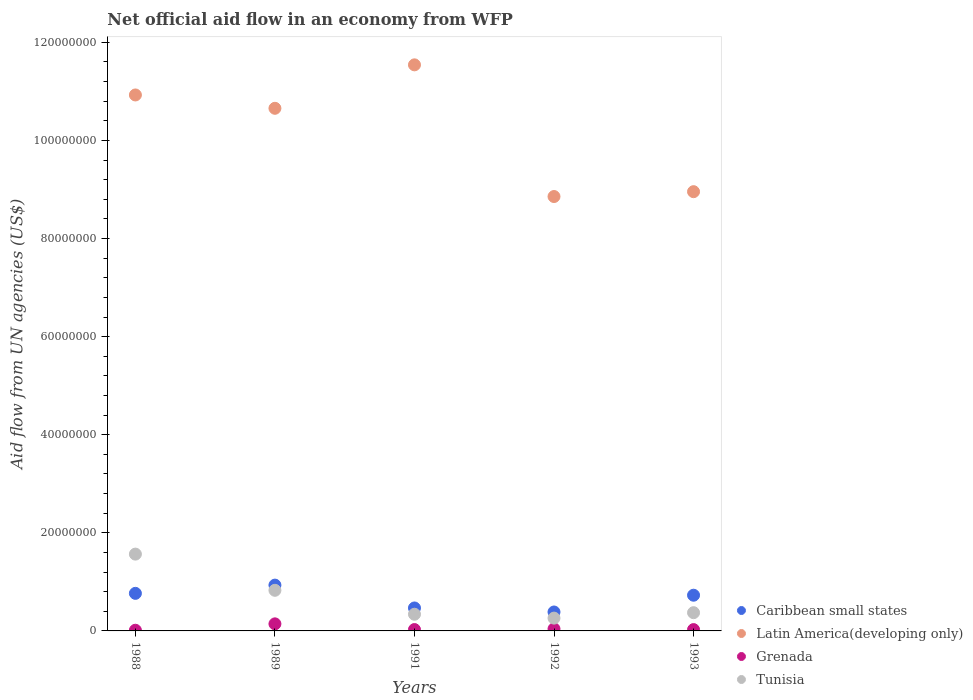How many different coloured dotlines are there?
Ensure brevity in your answer.  4. Is the number of dotlines equal to the number of legend labels?
Make the answer very short. Yes. Across all years, what is the maximum net official aid flow in Latin America(developing only)?
Keep it short and to the point. 1.15e+08. Across all years, what is the minimum net official aid flow in Caribbean small states?
Your answer should be very brief. 3.86e+06. In which year was the net official aid flow in Grenada minimum?
Offer a very short reply. 1988. What is the total net official aid flow in Latin America(developing only) in the graph?
Your response must be concise. 5.09e+08. What is the difference between the net official aid flow in Grenada in 1991 and that in 1992?
Provide a succinct answer. -1.40e+05. What is the difference between the net official aid flow in Tunisia in 1988 and the net official aid flow in Caribbean small states in 1992?
Offer a terse response. 1.18e+07. What is the average net official aid flow in Tunisia per year?
Ensure brevity in your answer.  6.73e+06. In the year 1991, what is the difference between the net official aid flow in Latin America(developing only) and net official aid flow in Tunisia?
Your response must be concise. 1.12e+08. What is the ratio of the net official aid flow in Caribbean small states in 1988 to that in 1991?
Ensure brevity in your answer.  1.64. Is the difference between the net official aid flow in Latin America(developing only) in 1991 and 1993 greater than the difference between the net official aid flow in Tunisia in 1991 and 1993?
Keep it short and to the point. Yes. What is the difference between the highest and the second highest net official aid flow in Caribbean small states?
Provide a succinct answer. 1.68e+06. What is the difference between the highest and the lowest net official aid flow in Tunisia?
Provide a succinct answer. 1.30e+07. In how many years, is the net official aid flow in Latin America(developing only) greater than the average net official aid flow in Latin America(developing only) taken over all years?
Provide a short and direct response. 3. Is the net official aid flow in Tunisia strictly greater than the net official aid flow in Latin America(developing only) over the years?
Ensure brevity in your answer.  No. How many dotlines are there?
Make the answer very short. 4. What is the difference between two consecutive major ticks on the Y-axis?
Provide a succinct answer. 2.00e+07. Does the graph contain any zero values?
Your answer should be very brief. No. How many legend labels are there?
Provide a succinct answer. 4. What is the title of the graph?
Make the answer very short. Net official aid flow in an economy from WFP. Does "Northern Mariana Islands" appear as one of the legend labels in the graph?
Your answer should be compact. No. What is the label or title of the Y-axis?
Provide a succinct answer. Aid flow from UN agencies (US$). What is the Aid flow from UN agencies (US$) in Caribbean small states in 1988?
Your response must be concise. 7.66e+06. What is the Aid flow from UN agencies (US$) of Latin America(developing only) in 1988?
Your answer should be compact. 1.09e+08. What is the Aid flow from UN agencies (US$) in Grenada in 1988?
Offer a terse response. 1.40e+05. What is the Aid flow from UN agencies (US$) in Tunisia in 1988?
Offer a terse response. 1.57e+07. What is the Aid flow from UN agencies (US$) in Caribbean small states in 1989?
Provide a short and direct response. 9.34e+06. What is the Aid flow from UN agencies (US$) of Latin America(developing only) in 1989?
Provide a succinct answer. 1.07e+08. What is the Aid flow from UN agencies (US$) in Grenada in 1989?
Offer a very short reply. 1.44e+06. What is the Aid flow from UN agencies (US$) in Tunisia in 1989?
Your answer should be very brief. 8.28e+06. What is the Aid flow from UN agencies (US$) in Caribbean small states in 1991?
Offer a terse response. 4.68e+06. What is the Aid flow from UN agencies (US$) in Latin America(developing only) in 1991?
Keep it short and to the point. 1.15e+08. What is the Aid flow from UN agencies (US$) in Tunisia in 1991?
Offer a terse response. 3.40e+06. What is the Aid flow from UN agencies (US$) in Caribbean small states in 1992?
Your answer should be compact. 3.86e+06. What is the Aid flow from UN agencies (US$) of Latin America(developing only) in 1992?
Provide a succinct answer. 8.86e+07. What is the Aid flow from UN agencies (US$) of Grenada in 1992?
Keep it short and to the point. 4.20e+05. What is the Aid flow from UN agencies (US$) of Tunisia in 1992?
Your answer should be compact. 2.61e+06. What is the Aid flow from UN agencies (US$) in Caribbean small states in 1993?
Your answer should be compact. 7.28e+06. What is the Aid flow from UN agencies (US$) in Latin America(developing only) in 1993?
Offer a very short reply. 8.96e+07. What is the Aid flow from UN agencies (US$) in Grenada in 1993?
Provide a succinct answer. 2.70e+05. What is the Aid flow from UN agencies (US$) in Tunisia in 1993?
Offer a very short reply. 3.72e+06. Across all years, what is the maximum Aid flow from UN agencies (US$) of Caribbean small states?
Keep it short and to the point. 9.34e+06. Across all years, what is the maximum Aid flow from UN agencies (US$) of Latin America(developing only)?
Keep it short and to the point. 1.15e+08. Across all years, what is the maximum Aid flow from UN agencies (US$) of Grenada?
Your response must be concise. 1.44e+06. Across all years, what is the maximum Aid flow from UN agencies (US$) in Tunisia?
Provide a short and direct response. 1.57e+07. Across all years, what is the minimum Aid flow from UN agencies (US$) in Caribbean small states?
Offer a very short reply. 3.86e+06. Across all years, what is the minimum Aid flow from UN agencies (US$) of Latin America(developing only)?
Offer a terse response. 8.86e+07. Across all years, what is the minimum Aid flow from UN agencies (US$) in Grenada?
Provide a short and direct response. 1.40e+05. Across all years, what is the minimum Aid flow from UN agencies (US$) of Tunisia?
Offer a terse response. 2.61e+06. What is the total Aid flow from UN agencies (US$) of Caribbean small states in the graph?
Offer a terse response. 3.28e+07. What is the total Aid flow from UN agencies (US$) in Latin America(developing only) in the graph?
Offer a terse response. 5.09e+08. What is the total Aid flow from UN agencies (US$) in Grenada in the graph?
Your answer should be very brief. 2.55e+06. What is the total Aid flow from UN agencies (US$) in Tunisia in the graph?
Ensure brevity in your answer.  3.37e+07. What is the difference between the Aid flow from UN agencies (US$) in Caribbean small states in 1988 and that in 1989?
Give a very brief answer. -1.68e+06. What is the difference between the Aid flow from UN agencies (US$) in Latin America(developing only) in 1988 and that in 1989?
Provide a short and direct response. 2.72e+06. What is the difference between the Aid flow from UN agencies (US$) in Grenada in 1988 and that in 1989?
Give a very brief answer. -1.30e+06. What is the difference between the Aid flow from UN agencies (US$) in Tunisia in 1988 and that in 1989?
Provide a succinct answer. 7.38e+06. What is the difference between the Aid flow from UN agencies (US$) in Caribbean small states in 1988 and that in 1991?
Give a very brief answer. 2.98e+06. What is the difference between the Aid flow from UN agencies (US$) in Latin America(developing only) in 1988 and that in 1991?
Ensure brevity in your answer.  -6.14e+06. What is the difference between the Aid flow from UN agencies (US$) of Grenada in 1988 and that in 1991?
Your response must be concise. -1.40e+05. What is the difference between the Aid flow from UN agencies (US$) of Tunisia in 1988 and that in 1991?
Provide a short and direct response. 1.23e+07. What is the difference between the Aid flow from UN agencies (US$) in Caribbean small states in 1988 and that in 1992?
Offer a very short reply. 3.80e+06. What is the difference between the Aid flow from UN agencies (US$) of Latin America(developing only) in 1988 and that in 1992?
Offer a very short reply. 2.07e+07. What is the difference between the Aid flow from UN agencies (US$) of Grenada in 1988 and that in 1992?
Keep it short and to the point. -2.80e+05. What is the difference between the Aid flow from UN agencies (US$) of Tunisia in 1988 and that in 1992?
Keep it short and to the point. 1.30e+07. What is the difference between the Aid flow from UN agencies (US$) of Latin America(developing only) in 1988 and that in 1993?
Provide a short and direct response. 1.97e+07. What is the difference between the Aid flow from UN agencies (US$) in Tunisia in 1988 and that in 1993?
Keep it short and to the point. 1.19e+07. What is the difference between the Aid flow from UN agencies (US$) of Caribbean small states in 1989 and that in 1991?
Offer a terse response. 4.66e+06. What is the difference between the Aid flow from UN agencies (US$) of Latin America(developing only) in 1989 and that in 1991?
Offer a terse response. -8.86e+06. What is the difference between the Aid flow from UN agencies (US$) of Grenada in 1989 and that in 1991?
Offer a terse response. 1.16e+06. What is the difference between the Aid flow from UN agencies (US$) of Tunisia in 1989 and that in 1991?
Provide a short and direct response. 4.88e+06. What is the difference between the Aid flow from UN agencies (US$) of Caribbean small states in 1989 and that in 1992?
Make the answer very short. 5.48e+06. What is the difference between the Aid flow from UN agencies (US$) of Latin America(developing only) in 1989 and that in 1992?
Keep it short and to the point. 1.80e+07. What is the difference between the Aid flow from UN agencies (US$) of Grenada in 1989 and that in 1992?
Make the answer very short. 1.02e+06. What is the difference between the Aid flow from UN agencies (US$) in Tunisia in 1989 and that in 1992?
Provide a short and direct response. 5.67e+06. What is the difference between the Aid flow from UN agencies (US$) in Caribbean small states in 1989 and that in 1993?
Your response must be concise. 2.06e+06. What is the difference between the Aid flow from UN agencies (US$) in Latin America(developing only) in 1989 and that in 1993?
Keep it short and to the point. 1.70e+07. What is the difference between the Aid flow from UN agencies (US$) of Grenada in 1989 and that in 1993?
Offer a very short reply. 1.17e+06. What is the difference between the Aid flow from UN agencies (US$) of Tunisia in 1989 and that in 1993?
Offer a very short reply. 4.56e+06. What is the difference between the Aid flow from UN agencies (US$) in Caribbean small states in 1991 and that in 1992?
Your response must be concise. 8.20e+05. What is the difference between the Aid flow from UN agencies (US$) in Latin America(developing only) in 1991 and that in 1992?
Keep it short and to the point. 2.68e+07. What is the difference between the Aid flow from UN agencies (US$) of Tunisia in 1991 and that in 1992?
Keep it short and to the point. 7.90e+05. What is the difference between the Aid flow from UN agencies (US$) in Caribbean small states in 1991 and that in 1993?
Keep it short and to the point. -2.60e+06. What is the difference between the Aid flow from UN agencies (US$) of Latin America(developing only) in 1991 and that in 1993?
Ensure brevity in your answer.  2.59e+07. What is the difference between the Aid flow from UN agencies (US$) of Grenada in 1991 and that in 1993?
Ensure brevity in your answer.  10000. What is the difference between the Aid flow from UN agencies (US$) of Tunisia in 1991 and that in 1993?
Your response must be concise. -3.20e+05. What is the difference between the Aid flow from UN agencies (US$) of Caribbean small states in 1992 and that in 1993?
Your answer should be very brief. -3.42e+06. What is the difference between the Aid flow from UN agencies (US$) of Latin America(developing only) in 1992 and that in 1993?
Make the answer very short. -9.90e+05. What is the difference between the Aid flow from UN agencies (US$) in Grenada in 1992 and that in 1993?
Provide a short and direct response. 1.50e+05. What is the difference between the Aid flow from UN agencies (US$) in Tunisia in 1992 and that in 1993?
Make the answer very short. -1.11e+06. What is the difference between the Aid flow from UN agencies (US$) in Caribbean small states in 1988 and the Aid flow from UN agencies (US$) in Latin America(developing only) in 1989?
Ensure brevity in your answer.  -9.89e+07. What is the difference between the Aid flow from UN agencies (US$) in Caribbean small states in 1988 and the Aid flow from UN agencies (US$) in Grenada in 1989?
Keep it short and to the point. 6.22e+06. What is the difference between the Aid flow from UN agencies (US$) of Caribbean small states in 1988 and the Aid flow from UN agencies (US$) of Tunisia in 1989?
Offer a terse response. -6.20e+05. What is the difference between the Aid flow from UN agencies (US$) in Latin America(developing only) in 1988 and the Aid flow from UN agencies (US$) in Grenada in 1989?
Offer a terse response. 1.08e+08. What is the difference between the Aid flow from UN agencies (US$) in Latin America(developing only) in 1988 and the Aid flow from UN agencies (US$) in Tunisia in 1989?
Keep it short and to the point. 1.01e+08. What is the difference between the Aid flow from UN agencies (US$) of Grenada in 1988 and the Aid flow from UN agencies (US$) of Tunisia in 1989?
Provide a succinct answer. -8.14e+06. What is the difference between the Aid flow from UN agencies (US$) of Caribbean small states in 1988 and the Aid flow from UN agencies (US$) of Latin America(developing only) in 1991?
Offer a very short reply. -1.08e+08. What is the difference between the Aid flow from UN agencies (US$) of Caribbean small states in 1988 and the Aid flow from UN agencies (US$) of Grenada in 1991?
Your response must be concise. 7.38e+06. What is the difference between the Aid flow from UN agencies (US$) in Caribbean small states in 1988 and the Aid flow from UN agencies (US$) in Tunisia in 1991?
Your answer should be very brief. 4.26e+06. What is the difference between the Aid flow from UN agencies (US$) of Latin America(developing only) in 1988 and the Aid flow from UN agencies (US$) of Grenada in 1991?
Your response must be concise. 1.09e+08. What is the difference between the Aid flow from UN agencies (US$) of Latin America(developing only) in 1988 and the Aid flow from UN agencies (US$) of Tunisia in 1991?
Offer a terse response. 1.06e+08. What is the difference between the Aid flow from UN agencies (US$) in Grenada in 1988 and the Aid flow from UN agencies (US$) in Tunisia in 1991?
Provide a succinct answer. -3.26e+06. What is the difference between the Aid flow from UN agencies (US$) in Caribbean small states in 1988 and the Aid flow from UN agencies (US$) in Latin America(developing only) in 1992?
Your response must be concise. -8.09e+07. What is the difference between the Aid flow from UN agencies (US$) of Caribbean small states in 1988 and the Aid flow from UN agencies (US$) of Grenada in 1992?
Your response must be concise. 7.24e+06. What is the difference between the Aid flow from UN agencies (US$) of Caribbean small states in 1988 and the Aid flow from UN agencies (US$) of Tunisia in 1992?
Keep it short and to the point. 5.05e+06. What is the difference between the Aid flow from UN agencies (US$) in Latin America(developing only) in 1988 and the Aid flow from UN agencies (US$) in Grenada in 1992?
Provide a succinct answer. 1.09e+08. What is the difference between the Aid flow from UN agencies (US$) of Latin America(developing only) in 1988 and the Aid flow from UN agencies (US$) of Tunisia in 1992?
Your response must be concise. 1.07e+08. What is the difference between the Aid flow from UN agencies (US$) in Grenada in 1988 and the Aid flow from UN agencies (US$) in Tunisia in 1992?
Offer a terse response. -2.47e+06. What is the difference between the Aid flow from UN agencies (US$) of Caribbean small states in 1988 and the Aid flow from UN agencies (US$) of Latin America(developing only) in 1993?
Your answer should be compact. -8.19e+07. What is the difference between the Aid flow from UN agencies (US$) in Caribbean small states in 1988 and the Aid flow from UN agencies (US$) in Grenada in 1993?
Offer a terse response. 7.39e+06. What is the difference between the Aid flow from UN agencies (US$) of Caribbean small states in 1988 and the Aid flow from UN agencies (US$) of Tunisia in 1993?
Your response must be concise. 3.94e+06. What is the difference between the Aid flow from UN agencies (US$) in Latin America(developing only) in 1988 and the Aid flow from UN agencies (US$) in Grenada in 1993?
Provide a succinct answer. 1.09e+08. What is the difference between the Aid flow from UN agencies (US$) of Latin America(developing only) in 1988 and the Aid flow from UN agencies (US$) of Tunisia in 1993?
Your answer should be very brief. 1.06e+08. What is the difference between the Aid flow from UN agencies (US$) of Grenada in 1988 and the Aid flow from UN agencies (US$) of Tunisia in 1993?
Ensure brevity in your answer.  -3.58e+06. What is the difference between the Aid flow from UN agencies (US$) of Caribbean small states in 1989 and the Aid flow from UN agencies (US$) of Latin America(developing only) in 1991?
Your answer should be very brief. -1.06e+08. What is the difference between the Aid flow from UN agencies (US$) in Caribbean small states in 1989 and the Aid flow from UN agencies (US$) in Grenada in 1991?
Ensure brevity in your answer.  9.06e+06. What is the difference between the Aid flow from UN agencies (US$) of Caribbean small states in 1989 and the Aid flow from UN agencies (US$) of Tunisia in 1991?
Your answer should be very brief. 5.94e+06. What is the difference between the Aid flow from UN agencies (US$) in Latin America(developing only) in 1989 and the Aid flow from UN agencies (US$) in Grenada in 1991?
Your response must be concise. 1.06e+08. What is the difference between the Aid flow from UN agencies (US$) of Latin America(developing only) in 1989 and the Aid flow from UN agencies (US$) of Tunisia in 1991?
Your answer should be compact. 1.03e+08. What is the difference between the Aid flow from UN agencies (US$) in Grenada in 1989 and the Aid flow from UN agencies (US$) in Tunisia in 1991?
Your answer should be compact. -1.96e+06. What is the difference between the Aid flow from UN agencies (US$) in Caribbean small states in 1989 and the Aid flow from UN agencies (US$) in Latin America(developing only) in 1992?
Offer a terse response. -7.92e+07. What is the difference between the Aid flow from UN agencies (US$) of Caribbean small states in 1989 and the Aid flow from UN agencies (US$) of Grenada in 1992?
Your answer should be compact. 8.92e+06. What is the difference between the Aid flow from UN agencies (US$) in Caribbean small states in 1989 and the Aid flow from UN agencies (US$) in Tunisia in 1992?
Give a very brief answer. 6.73e+06. What is the difference between the Aid flow from UN agencies (US$) of Latin America(developing only) in 1989 and the Aid flow from UN agencies (US$) of Grenada in 1992?
Your answer should be very brief. 1.06e+08. What is the difference between the Aid flow from UN agencies (US$) of Latin America(developing only) in 1989 and the Aid flow from UN agencies (US$) of Tunisia in 1992?
Keep it short and to the point. 1.04e+08. What is the difference between the Aid flow from UN agencies (US$) of Grenada in 1989 and the Aid flow from UN agencies (US$) of Tunisia in 1992?
Make the answer very short. -1.17e+06. What is the difference between the Aid flow from UN agencies (US$) in Caribbean small states in 1989 and the Aid flow from UN agencies (US$) in Latin America(developing only) in 1993?
Make the answer very short. -8.02e+07. What is the difference between the Aid flow from UN agencies (US$) in Caribbean small states in 1989 and the Aid flow from UN agencies (US$) in Grenada in 1993?
Make the answer very short. 9.07e+06. What is the difference between the Aid flow from UN agencies (US$) of Caribbean small states in 1989 and the Aid flow from UN agencies (US$) of Tunisia in 1993?
Offer a very short reply. 5.62e+06. What is the difference between the Aid flow from UN agencies (US$) in Latin America(developing only) in 1989 and the Aid flow from UN agencies (US$) in Grenada in 1993?
Your answer should be very brief. 1.06e+08. What is the difference between the Aid flow from UN agencies (US$) in Latin America(developing only) in 1989 and the Aid flow from UN agencies (US$) in Tunisia in 1993?
Offer a very short reply. 1.03e+08. What is the difference between the Aid flow from UN agencies (US$) of Grenada in 1989 and the Aid flow from UN agencies (US$) of Tunisia in 1993?
Give a very brief answer. -2.28e+06. What is the difference between the Aid flow from UN agencies (US$) of Caribbean small states in 1991 and the Aid flow from UN agencies (US$) of Latin America(developing only) in 1992?
Your answer should be compact. -8.39e+07. What is the difference between the Aid flow from UN agencies (US$) of Caribbean small states in 1991 and the Aid flow from UN agencies (US$) of Grenada in 1992?
Your answer should be very brief. 4.26e+06. What is the difference between the Aid flow from UN agencies (US$) of Caribbean small states in 1991 and the Aid flow from UN agencies (US$) of Tunisia in 1992?
Your answer should be compact. 2.07e+06. What is the difference between the Aid flow from UN agencies (US$) of Latin America(developing only) in 1991 and the Aid flow from UN agencies (US$) of Grenada in 1992?
Your answer should be very brief. 1.15e+08. What is the difference between the Aid flow from UN agencies (US$) in Latin America(developing only) in 1991 and the Aid flow from UN agencies (US$) in Tunisia in 1992?
Provide a short and direct response. 1.13e+08. What is the difference between the Aid flow from UN agencies (US$) in Grenada in 1991 and the Aid flow from UN agencies (US$) in Tunisia in 1992?
Offer a terse response. -2.33e+06. What is the difference between the Aid flow from UN agencies (US$) of Caribbean small states in 1991 and the Aid flow from UN agencies (US$) of Latin America(developing only) in 1993?
Make the answer very short. -8.49e+07. What is the difference between the Aid flow from UN agencies (US$) in Caribbean small states in 1991 and the Aid flow from UN agencies (US$) in Grenada in 1993?
Make the answer very short. 4.41e+06. What is the difference between the Aid flow from UN agencies (US$) in Caribbean small states in 1991 and the Aid flow from UN agencies (US$) in Tunisia in 1993?
Offer a terse response. 9.60e+05. What is the difference between the Aid flow from UN agencies (US$) of Latin America(developing only) in 1991 and the Aid flow from UN agencies (US$) of Grenada in 1993?
Your answer should be compact. 1.15e+08. What is the difference between the Aid flow from UN agencies (US$) in Latin America(developing only) in 1991 and the Aid flow from UN agencies (US$) in Tunisia in 1993?
Ensure brevity in your answer.  1.12e+08. What is the difference between the Aid flow from UN agencies (US$) in Grenada in 1991 and the Aid flow from UN agencies (US$) in Tunisia in 1993?
Offer a terse response. -3.44e+06. What is the difference between the Aid flow from UN agencies (US$) of Caribbean small states in 1992 and the Aid flow from UN agencies (US$) of Latin America(developing only) in 1993?
Give a very brief answer. -8.57e+07. What is the difference between the Aid flow from UN agencies (US$) in Caribbean small states in 1992 and the Aid flow from UN agencies (US$) in Grenada in 1993?
Offer a terse response. 3.59e+06. What is the difference between the Aid flow from UN agencies (US$) of Caribbean small states in 1992 and the Aid flow from UN agencies (US$) of Tunisia in 1993?
Give a very brief answer. 1.40e+05. What is the difference between the Aid flow from UN agencies (US$) in Latin America(developing only) in 1992 and the Aid flow from UN agencies (US$) in Grenada in 1993?
Keep it short and to the point. 8.83e+07. What is the difference between the Aid flow from UN agencies (US$) in Latin America(developing only) in 1992 and the Aid flow from UN agencies (US$) in Tunisia in 1993?
Ensure brevity in your answer.  8.48e+07. What is the difference between the Aid flow from UN agencies (US$) in Grenada in 1992 and the Aid flow from UN agencies (US$) in Tunisia in 1993?
Your answer should be compact. -3.30e+06. What is the average Aid flow from UN agencies (US$) in Caribbean small states per year?
Your response must be concise. 6.56e+06. What is the average Aid flow from UN agencies (US$) in Latin America(developing only) per year?
Give a very brief answer. 1.02e+08. What is the average Aid flow from UN agencies (US$) in Grenada per year?
Your answer should be very brief. 5.10e+05. What is the average Aid flow from UN agencies (US$) of Tunisia per year?
Offer a very short reply. 6.73e+06. In the year 1988, what is the difference between the Aid flow from UN agencies (US$) in Caribbean small states and Aid flow from UN agencies (US$) in Latin America(developing only)?
Offer a very short reply. -1.02e+08. In the year 1988, what is the difference between the Aid flow from UN agencies (US$) in Caribbean small states and Aid flow from UN agencies (US$) in Grenada?
Give a very brief answer. 7.52e+06. In the year 1988, what is the difference between the Aid flow from UN agencies (US$) of Caribbean small states and Aid flow from UN agencies (US$) of Tunisia?
Your response must be concise. -8.00e+06. In the year 1988, what is the difference between the Aid flow from UN agencies (US$) in Latin America(developing only) and Aid flow from UN agencies (US$) in Grenada?
Keep it short and to the point. 1.09e+08. In the year 1988, what is the difference between the Aid flow from UN agencies (US$) of Latin America(developing only) and Aid flow from UN agencies (US$) of Tunisia?
Provide a succinct answer. 9.36e+07. In the year 1988, what is the difference between the Aid flow from UN agencies (US$) in Grenada and Aid flow from UN agencies (US$) in Tunisia?
Offer a terse response. -1.55e+07. In the year 1989, what is the difference between the Aid flow from UN agencies (US$) in Caribbean small states and Aid flow from UN agencies (US$) in Latin America(developing only)?
Your answer should be very brief. -9.72e+07. In the year 1989, what is the difference between the Aid flow from UN agencies (US$) in Caribbean small states and Aid flow from UN agencies (US$) in Grenada?
Your response must be concise. 7.90e+06. In the year 1989, what is the difference between the Aid flow from UN agencies (US$) of Caribbean small states and Aid flow from UN agencies (US$) of Tunisia?
Offer a terse response. 1.06e+06. In the year 1989, what is the difference between the Aid flow from UN agencies (US$) in Latin America(developing only) and Aid flow from UN agencies (US$) in Grenada?
Provide a succinct answer. 1.05e+08. In the year 1989, what is the difference between the Aid flow from UN agencies (US$) of Latin America(developing only) and Aid flow from UN agencies (US$) of Tunisia?
Give a very brief answer. 9.83e+07. In the year 1989, what is the difference between the Aid flow from UN agencies (US$) of Grenada and Aid flow from UN agencies (US$) of Tunisia?
Make the answer very short. -6.84e+06. In the year 1991, what is the difference between the Aid flow from UN agencies (US$) of Caribbean small states and Aid flow from UN agencies (US$) of Latin America(developing only)?
Make the answer very short. -1.11e+08. In the year 1991, what is the difference between the Aid flow from UN agencies (US$) in Caribbean small states and Aid flow from UN agencies (US$) in Grenada?
Offer a terse response. 4.40e+06. In the year 1991, what is the difference between the Aid flow from UN agencies (US$) of Caribbean small states and Aid flow from UN agencies (US$) of Tunisia?
Offer a terse response. 1.28e+06. In the year 1991, what is the difference between the Aid flow from UN agencies (US$) of Latin America(developing only) and Aid flow from UN agencies (US$) of Grenada?
Give a very brief answer. 1.15e+08. In the year 1991, what is the difference between the Aid flow from UN agencies (US$) of Latin America(developing only) and Aid flow from UN agencies (US$) of Tunisia?
Your answer should be compact. 1.12e+08. In the year 1991, what is the difference between the Aid flow from UN agencies (US$) of Grenada and Aid flow from UN agencies (US$) of Tunisia?
Make the answer very short. -3.12e+06. In the year 1992, what is the difference between the Aid flow from UN agencies (US$) of Caribbean small states and Aid flow from UN agencies (US$) of Latin America(developing only)?
Provide a short and direct response. -8.47e+07. In the year 1992, what is the difference between the Aid flow from UN agencies (US$) in Caribbean small states and Aid flow from UN agencies (US$) in Grenada?
Offer a very short reply. 3.44e+06. In the year 1992, what is the difference between the Aid flow from UN agencies (US$) of Caribbean small states and Aid flow from UN agencies (US$) of Tunisia?
Keep it short and to the point. 1.25e+06. In the year 1992, what is the difference between the Aid flow from UN agencies (US$) in Latin America(developing only) and Aid flow from UN agencies (US$) in Grenada?
Keep it short and to the point. 8.82e+07. In the year 1992, what is the difference between the Aid flow from UN agencies (US$) in Latin America(developing only) and Aid flow from UN agencies (US$) in Tunisia?
Offer a terse response. 8.60e+07. In the year 1992, what is the difference between the Aid flow from UN agencies (US$) of Grenada and Aid flow from UN agencies (US$) of Tunisia?
Keep it short and to the point. -2.19e+06. In the year 1993, what is the difference between the Aid flow from UN agencies (US$) of Caribbean small states and Aid flow from UN agencies (US$) of Latin America(developing only)?
Make the answer very short. -8.23e+07. In the year 1993, what is the difference between the Aid flow from UN agencies (US$) of Caribbean small states and Aid flow from UN agencies (US$) of Grenada?
Offer a terse response. 7.01e+06. In the year 1993, what is the difference between the Aid flow from UN agencies (US$) of Caribbean small states and Aid flow from UN agencies (US$) of Tunisia?
Your answer should be compact. 3.56e+06. In the year 1993, what is the difference between the Aid flow from UN agencies (US$) in Latin America(developing only) and Aid flow from UN agencies (US$) in Grenada?
Ensure brevity in your answer.  8.93e+07. In the year 1993, what is the difference between the Aid flow from UN agencies (US$) of Latin America(developing only) and Aid flow from UN agencies (US$) of Tunisia?
Give a very brief answer. 8.58e+07. In the year 1993, what is the difference between the Aid flow from UN agencies (US$) in Grenada and Aid flow from UN agencies (US$) in Tunisia?
Give a very brief answer. -3.45e+06. What is the ratio of the Aid flow from UN agencies (US$) in Caribbean small states in 1988 to that in 1989?
Offer a very short reply. 0.82. What is the ratio of the Aid flow from UN agencies (US$) of Latin America(developing only) in 1988 to that in 1989?
Offer a very short reply. 1.03. What is the ratio of the Aid flow from UN agencies (US$) of Grenada in 1988 to that in 1989?
Offer a terse response. 0.1. What is the ratio of the Aid flow from UN agencies (US$) of Tunisia in 1988 to that in 1989?
Your response must be concise. 1.89. What is the ratio of the Aid flow from UN agencies (US$) of Caribbean small states in 1988 to that in 1991?
Your response must be concise. 1.64. What is the ratio of the Aid flow from UN agencies (US$) in Latin America(developing only) in 1988 to that in 1991?
Your answer should be very brief. 0.95. What is the ratio of the Aid flow from UN agencies (US$) of Tunisia in 1988 to that in 1991?
Ensure brevity in your answer.  4.61. What is the ratio of the Aid flow from UN agencies (US$) in Caribbean small states in 1988 to that in 1992?
Keep it short and to the point. 1.98. What is the ratio of the Aid flow from UN agencies (US$) of Latin America(developing only) in 1988 to that in 1992?
Offer a terse response. 1.23. What is the ratio of the Aid flow from UN agencies (US$) in Grenada in 1988 to that in 1992?
Give a very brief answer. 0.33. What is the ratio of the Aid flow from UN agencies (US$) in Caribbean small states in 1988 to that in 1993?
Ensure brevity in your answer.  1.05. What is the ratio of the Aid flow from UN agencies (US$) in Latin America(developing only) in 1988 to that in 1993?
Make the answer very short. 1.22. What is the ratio of the Aid flow from UN agencies (US$) of Grenada in 1988 to that in 1993?
Offer a very short reply. 0.52. What is the ratio of the Aid flow from UN agencies (US$) of Tunisia in 1988 to that in 1993?
Offer a terse response. 4.21. What is the ratio of the Aid flow from UN agencies (US$) of Caribbean small states in 1989 to that in 1991?
Provide a short and direct response. 2. What is the ratio of the Aid flow from UN agencies (US$) of Latin America(developing only) in 1989 to that in 1991?
Offer a very short reply. 0.92. What is the ratio of the Aid flow from UN agencies (US$) of Grenada in 1989 to that in 1991?
Your answer should be compact. 5.14. What is the ratio of the Aid flow from UN agencies (US$) in Tunisia in 1989 to that in 1991?
Give a very brief answer. 2.44. What is the ratio of the Aid flow from UN agencies (US$) of Caribbean small states in 1989 to that in 1992?
Make the answer very short. 2.42. What is the ratio of the Aid flow from UN agencies (US$) in Latin America(developing only) in 1989 to that in 1992?
Your answer should be compact. 1.2. What is the ratio of the Aid flow from UN agencies (US$) in Grenada in 1989 to that in 1992?
Offer a very short reply. 3.43. What is the ratio of the Aid flow from UN agencies (US$) in Tunisia in 1989 to that in 1992?
Offer a very short reply. 3.17. What is the ratio of the Aid flow from UN agencies (US$) of Caribbean small states in 1989 to that in 1993?
Offer a terse response. 1.28. What is the ratio of the Aid flow from UN agencies (US$) in Latin America(developing only) in 1989 to that in 1993?
Your answer should be very brief. 1.19. What is the ratio of the Aid flow from UN agencies (US$) in Grenada in 1989 to that in 1993?
Your answer should be compact. 5.33. What is the ratio of the Aid flow from UN agencies (US$) in Tunisia in 1989 to that in 1993?
Offer a very short reply. 2.23. What is the ratio of the Aid flow from UN agencies (US$) in Caribbean small states in 1991 to that in 1992?
Give a very brief answer. 1.21. What is the ratio of the Aid flow from UN agencies (US$) in Latin America(developing only) in 1991 to that in 1992?
Your answer should be very brief. 1.3. What is the ratio of the Aid flow from UN agencies (US$) in Grenada in 1991 to that in 1992?
Provide a short and direct response. 0.67. What is the ratio of the Aid flow from UN agencies (US$) in Tunisia in 1991 to that in 1992?
Keep it short and to the point. 1.3. What is the ratio of the Aid flow from UN agencies (US$) in Caribbean small states in 1991 to that in 1993?
Offer a terse response. 0.64. What is the ratio of the Aid flow from UN agencies (US$) of Latin America(developing only) in 1991 to that in 1993?
Your response must be concise. 1.29. What is the ratio of the Aid flow from UN agencies (US$) of Grenada in 1991 to that in 1993?
Ensure brevity in your answer.  1.04. What is the ratio of the Aid flow from UN agencies (US$) in Tunisia in 1991 to that in 1993?
Offer a terse response. 0.91. What is the ratio of the Aid flow from UN agencies (US$) in Caribbean small states in 1992 to that in 1993?
Offer a very short reply. 0.53. What is the ratio of the Aid flow from UN agencies (US$) in Latin America(developing only) in 1992 to that in 1993?
Your response must be concise. 0.99. What is the ratio of the Aid flow from UN agencies (US$) in Grenada in 1992 to that in 1993?
Your response must be concise. 1.56. What is the ratio of the Aid flow from UN agencies (US$) in Tunisia in 1992 to that in 1993?
Your answer should be very brief. 0.7. What is the difference between the highest and the second highest Aid flow from UN agencies (US$) in Caribbean small states?
Provide a succinct answer. 1.68e+06. What is the difference between the highest and the second highest Aid flow from UN agencies (US$) of Latin America(developing only)?
Provide a succinct answer. 6.14e+06. What is the difference between the highest and the second highest Aid flow from UN agencies (US$) in Grenada?
Keep it short and to the point. 1.02e+06. What is the difference between the highest and the second highest Aid flow from UN agencies (US$) in Tunisia?
Ensure brevity in your answer.  7.38e+06. What is the difference between the highest and the lowest Aid flow from UN agencies (US$) in Caribbean small states?
Ensure brevity in your answer.  5.48e+06. What is the difference between the highest and the lowest Aid flow from UN agencies (US$) in Latin America(developing only)?
Offer a very short reply. 2.68e+07. What is the difference between the highest and the lowest Aid flow from UN agencies (US$) in Grenada?
Provide a short and direct response. 1.30e+06. What is the difference between the highest and the lowest Aid flow from UN agencies (US$) in Tunisia?
Ensure brevity in your answer.  1.30e+07. 